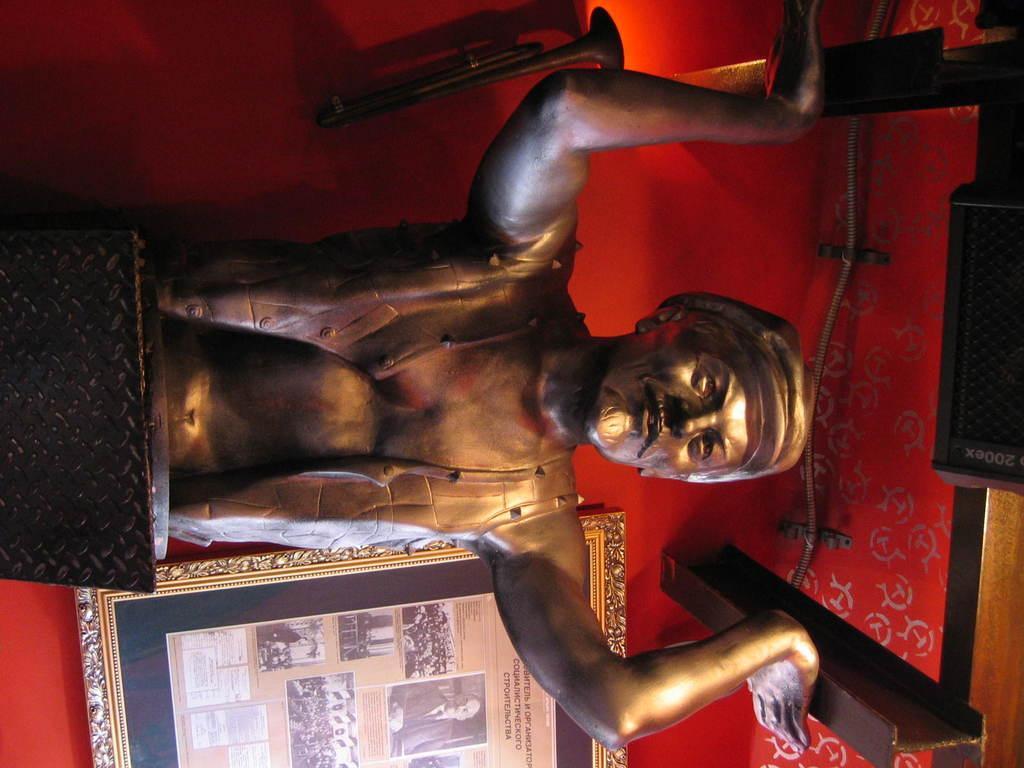Describe this image in one or two sentences. This image is taken indoors. In the background there is a wall with a picture frame on it. On the right side of the image there is a roof and there are two iron bars. In the middle of the image there is a statue of a man. 